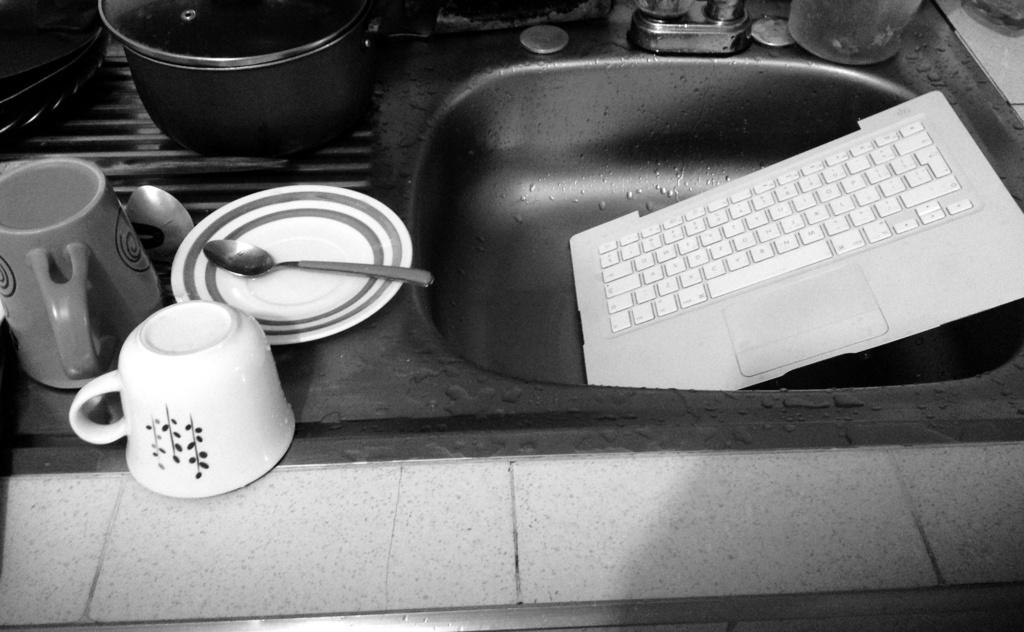What type of tableware can be seen in the image? There are cups, a plate, and spoons in the image. What is the primary location of these items in the image? The items are in a sink. What other object is visible in the image? There is a keyboard in the image. What can be seen in the background of the image? There are vessels visible in the background. How is the image presented? The image is in black and white. What type of plant is growing on the keyboard in the image? There is no plant growing on the keyboard in the image; the keyboard is the only object visible on it. What type of band is performing in the image? There is no band performing in the image; the image features tableware, a keyboard, and vessels in a sink. 